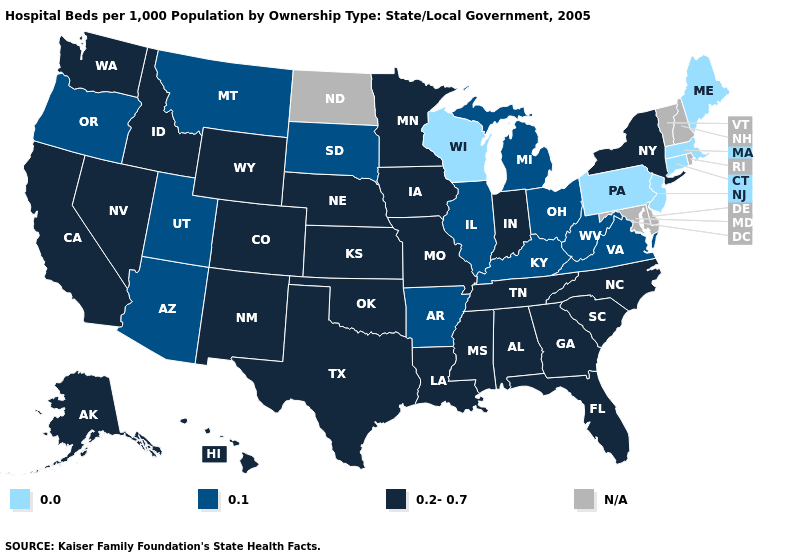How many symbols are there in the legend?
Quick response, please. 4. Does Michigan have the highest value in the MidWest?
Give a very brief answer. No. Name the states that have a value in the range N/A?
Quick response, please. Delaware, Maryland, New Hampshire, North Dakota, Rhode Island, Vermont. Name the states that have a value in the range 0.2-0.7?
Short answer required. Alabama, Alaska, California, Colorado, Florida, Georgia, Hawaii, Idaho, Indiana, Iowa, Kansas, Louisiana, Minnesota, Mississippi, Missouri, Nebraska, Nevada, New Mexico, New York, North Carolina, Oklahoma, South Carolina, Tennessee, Texas, Washington, Wyoming. Name the states that have a value in the range N/A?
Give a very brief answer. Delaware, Maryland, New Hampshire, North Dakota, Rhode Island, Vermont. Name the states that have a value in the range 0.1?
Write a very short answer. Arizona, Arkansas, Illinois, Kentucky, Michigan, Montana, Ohio, Oregon, South Dakota, Utah, Virginia, West Virginia. What is the value of Mississippi?
Give a very brief answer. 0.2-0.7. Which states have the highest value in the USA?
Keep it brief. Alabama, Alaska, California, Colorado, Florida, Georgia, Hawaii, Idaho, Indiana, Iowa, Kansas, Louisiana, Minnesota, Mississippi, Missouri, Nebraska, Nevada, New Mexico, New York, North Carolina, Oklahoma, South Carolina, Tennessee, Texas, Washington, Wyoming. Does the first symbol in the legend represent the smallest category?
Answer briefly. Yes. What is the lowest value in the USA?
Concise answer only. 0.0. Name the states that have a value in the range 0.2-0.7?
Quick response, please. Alabama, Alaska, California, Colorado, Florida, Georgia, Hawaii, Idaho, Indiana, Iowa, Kansas, Louisiana, Minnesota, Mississippi, Missouri, Nebraska, Nevada, New Mexico, New York, North Carolina, Oklahoma, South Carolina, Tennessee, Texas, Washington, Wyoming. Name the states that have a value in the range 0.2-0.7?
Give a very brief answer. Alabama, Alaska, California, Colorado, Florida, Georgia, Hawaii, Idaho, Indiana, Iowa, Kansas, Louisiana, Minnesota, Mississippi, Missouri, Nebraska, Nevada, New Mexico, New York, North Carolina, Oklahoma, South Carolina, Tennessee, Texas, Washington, Wyoming. Name the states that have a value in the range N/A?
Be succinct. Delaware, Maryland, New Hampshire, North Dakota, Rhode Island, Vermont. What is the value of Utah?
Keep it brief. 0.1. Does South Dakota have the highest value in the USA?
Write a very short answer. No. 